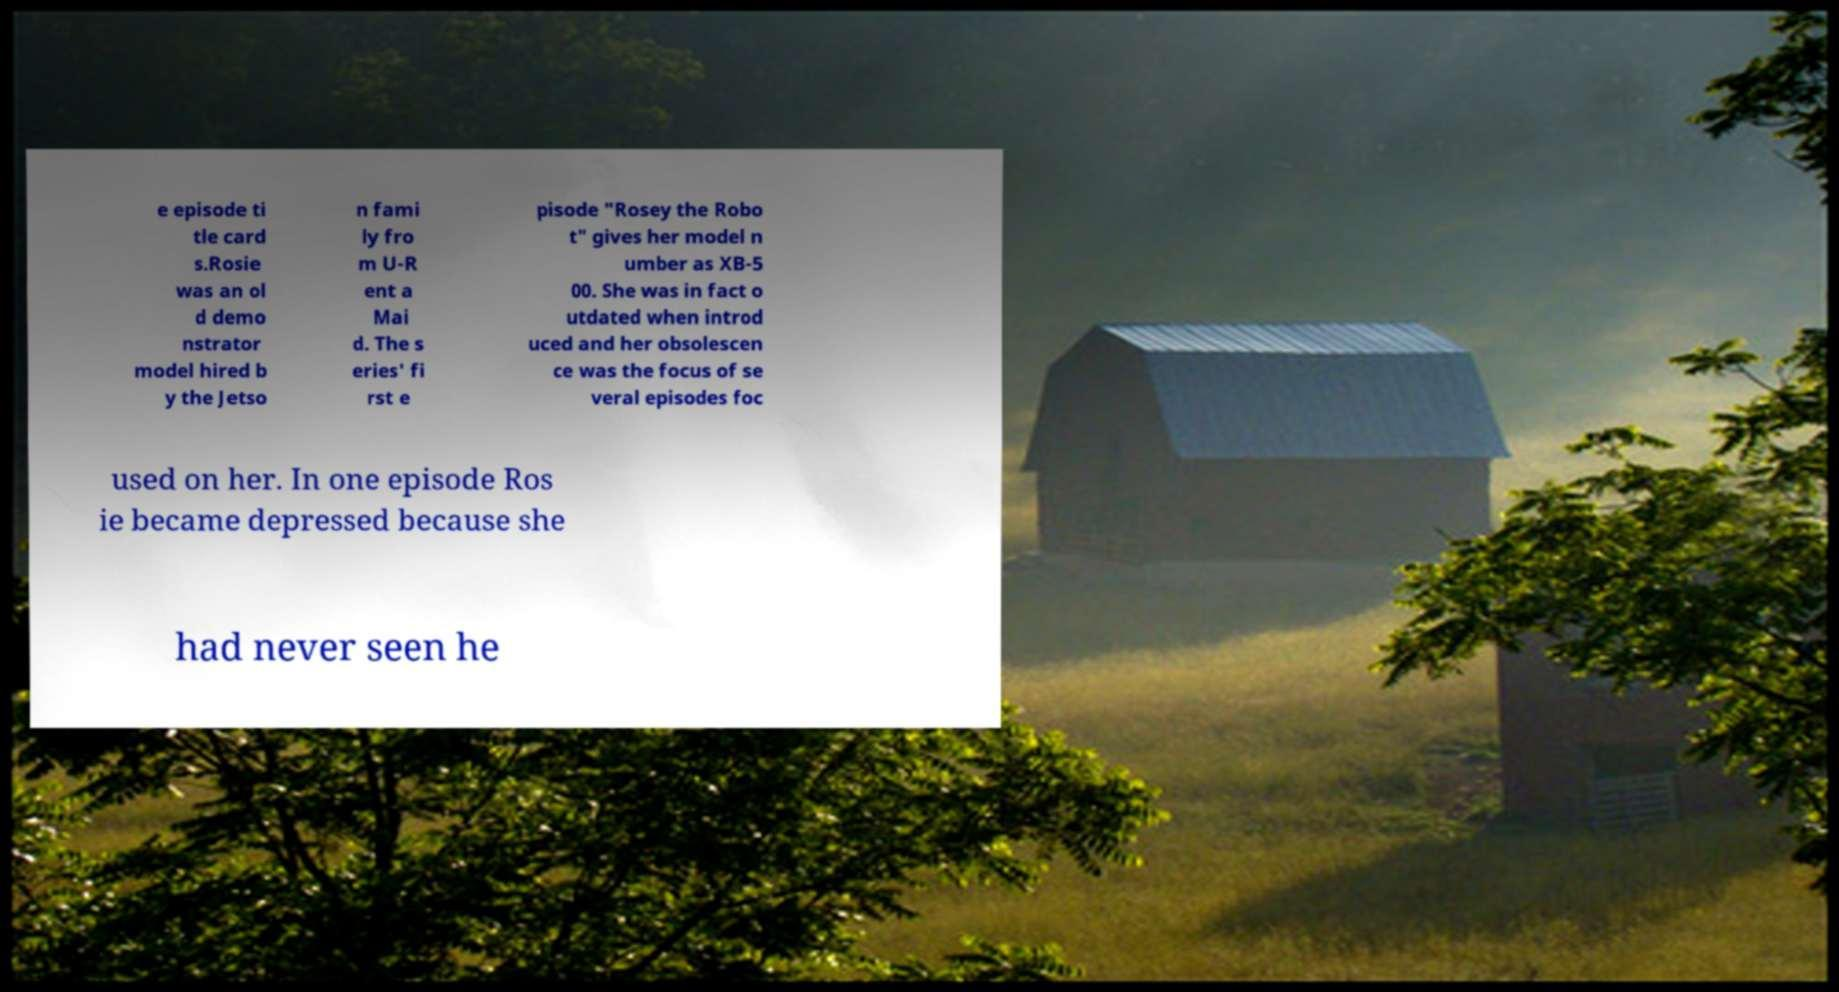Can you accurately transcribe the text from the provided image for me? e episode ti tle card s.Rosie was an ol d demo nstrator model hired b y the Jetso n fami ly fro m U-R ent a Mai d. The s eries' fi rst e pisode "Rosey the Robo t" gives her model n umber as XB-5 00. She was in fact o utdated when introd uced and her obsolescen ce was the focus of se veral episodes foc used on her. In one episode Ros ie became depressed because she had never seen he 